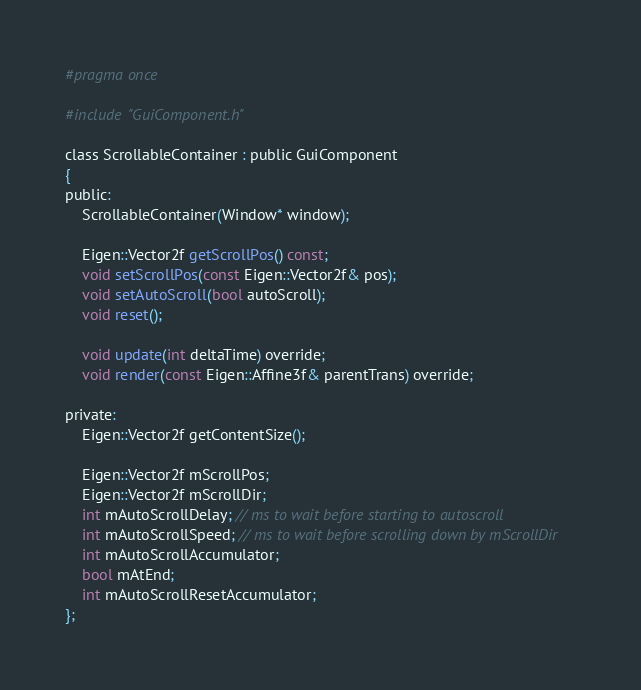Convert code to text. <code><loc_0><loc_0><loc_500><loc_500><_C_>#pragma once

#include "GuiComponent.h"

class ScrollableContainer : public GuiComponent
{
public:
	ScrollableContainer(Window* window);

	Eigen::Vector2f getScrollPos() const;
	void setScrollPos(const Eigen::Vector2f& pos);
	void setAutoScroll(bool autoScroll);
	void reset();

	void update(int deltaTime) override;
	void render(const Eigen::Affine3f& parentTrans) override;

private:
	Eigen::Vector2f getContentSize();

	Eigen::Vector2f mScrollPos;
	Eigen::Vector2f mScrollDir;
	int mAutoScrollDelay; // ms to wait before starting to autoscroll
	int mAutoScrollSpeed; // ms to wait before scrolling down by mScrollDir
	int mAutoScrollAccumulator;
	bool mAtEnd;
	int mAutoScrollResetAccumulator;
};
</code> 